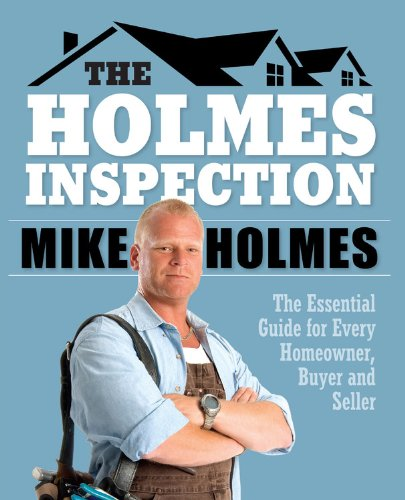What is the title of this book? The title of the book is 'Holmes Inspection: The Essential Guide for Every Homeowner, Buyer and Seller,' offering valuable insights into home inspections. 